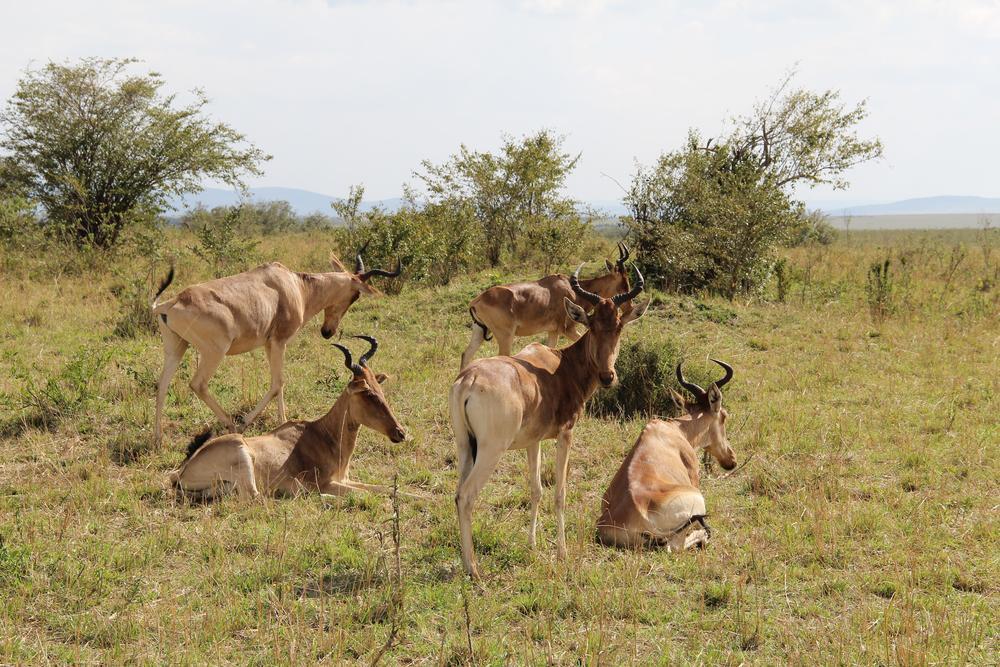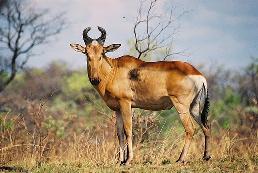The first image is the image on the left, the second image is the image on the right. Assess this claim about the two images: "An image shows exactly two horned animals, which are facing each other.". Correct or not? Answer yes or no. No. The first image is the image on the left, the second image is the image on the right. Analyze the images presented: Is the assertion "There is an animal looks straight at the camera" valid? Answer yes or no. Yes. 